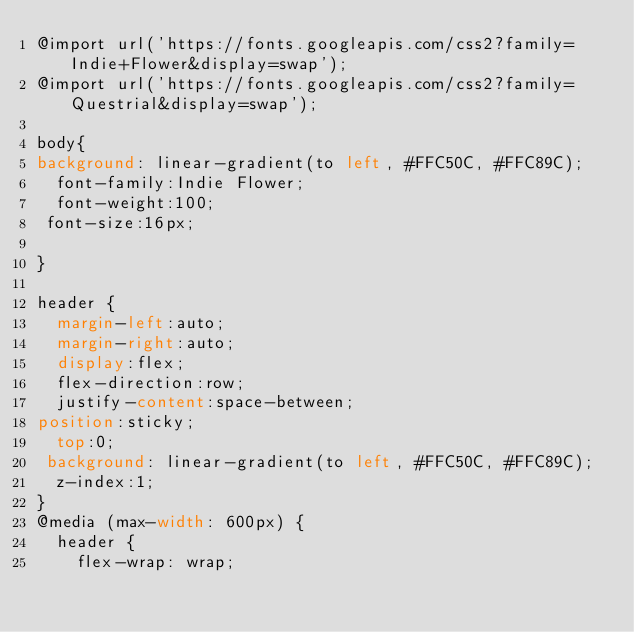Convert code to text. <code><loc_0><loc_0><loc_500><loc_500><_CSS_>@import url('https://fonts.googleapis.com/css2?family=Indie+Flower&display=swap');
@import url('https://fonts.googleapis.com/css2?family=Questrial&display=swap');

body{
background: linear-gradient(to left, #FFC50C, #FFC89C);
  font-family:Indie Flower;
  font-weight:100;
 font-size:16px; 
 
}

header {
  margin-left:auto;
  margin-right:auto;
  display:flex;
  flex-direction:row;
  justify-content:space-between;
position:sticky;
  top:0;
 background: linear-gradient(to left, #FFC50C, #FFC89C);
  z-index:1;
}
@media (max-width: 600px) {
  header {
    flex-wrap: wrap;</code> 